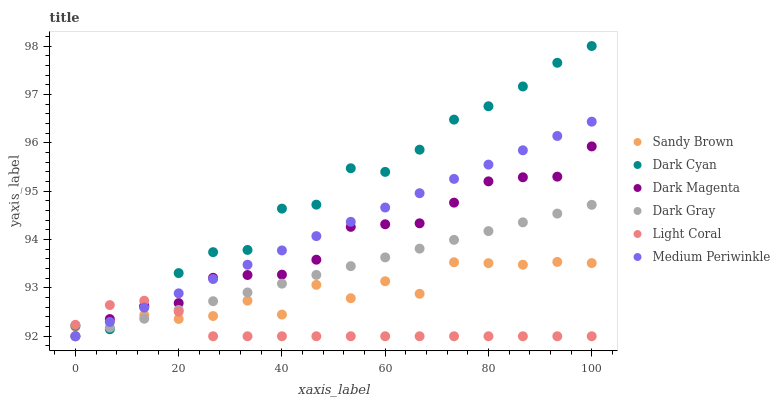Does Light Coral have the minimum area under the curve?
Answer yes or no. Yes. Does Dark Cyan have the maximum area under the curve?
Answer yes or no. Yes. Does Dark Magenta have the minimum area under the curve?
Answer yes or no. No. Does Dark Magenta have the maximum area under the curve?
Answer yes or no. No. Is Dark Gray the smoothest?
Answer yes or no. Yes. Is Sandy Brown the roughest?
Answer yes or no. Yes. Is Dark Magenta the smoothest?
Answer yes or no. No. Is Dark Magenta the roughest?
Answer yes or no. No. Does Light Coral have the lowest value?
Answer yes or no. Yes. Does Dark Cyan have the lowest value?
Answer yes or no. No. Does Dark Cyan have the highest value?
Answer yes or no. Yes. Does Dark Magenta have the highest value?
Answer yes or no. No. Does Dark Gray intersect Medium Periwinkle?
Answer yes or no. Yes. Is Dark Gray less than Medium Periwinkle?
Answer yes or no. No. Is Dark Gray greater than Medium Periwinkle?
Answer yes or no. No. 